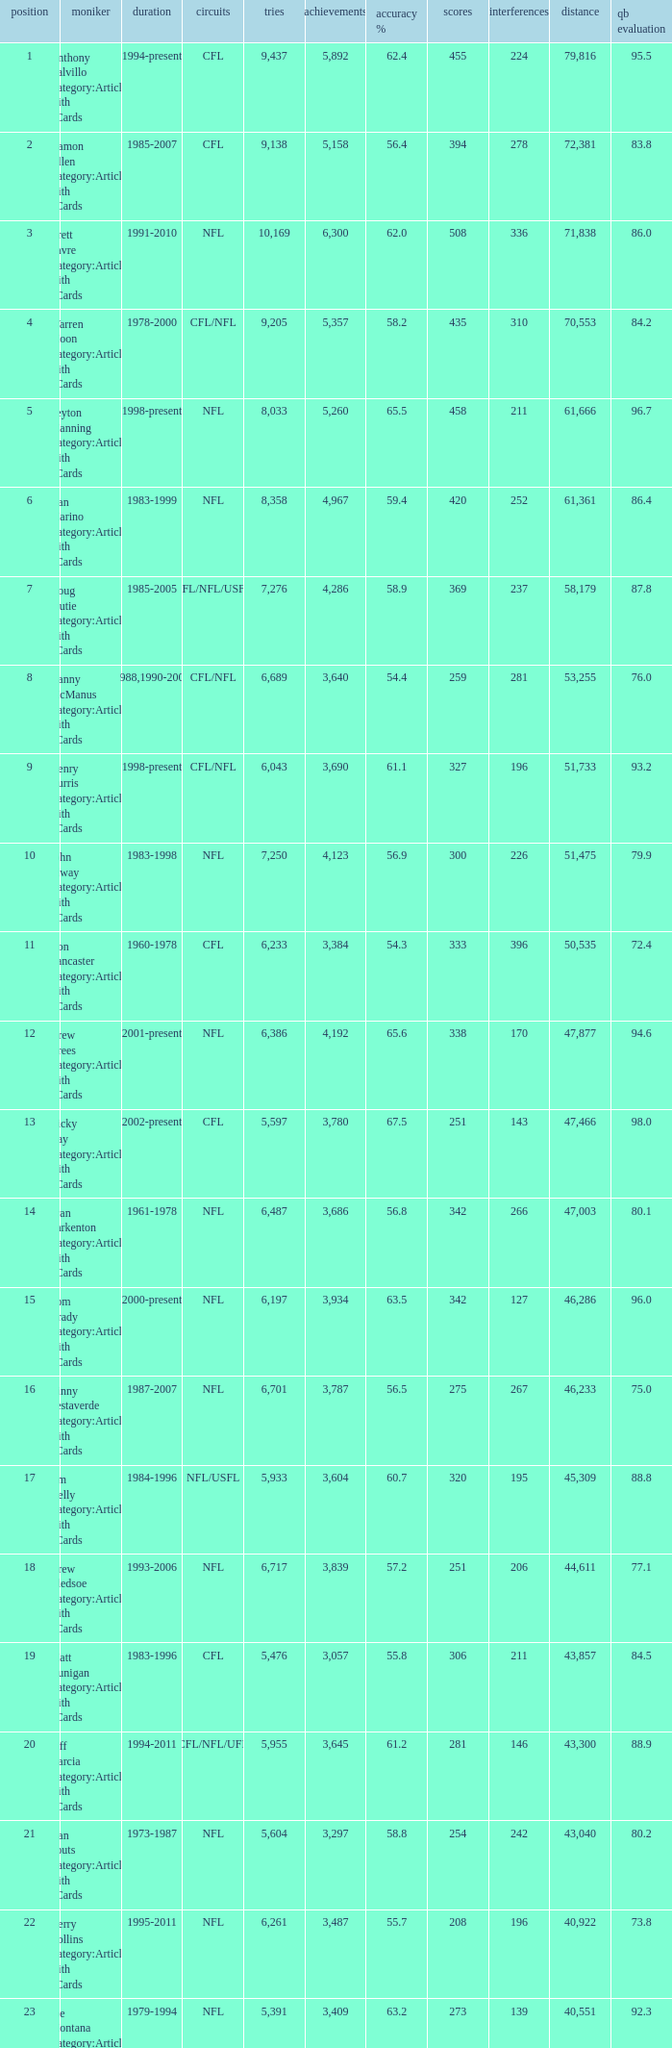What is the rank when there are more than 4,123 completion and the comp percentage is more than 65.6? None. 